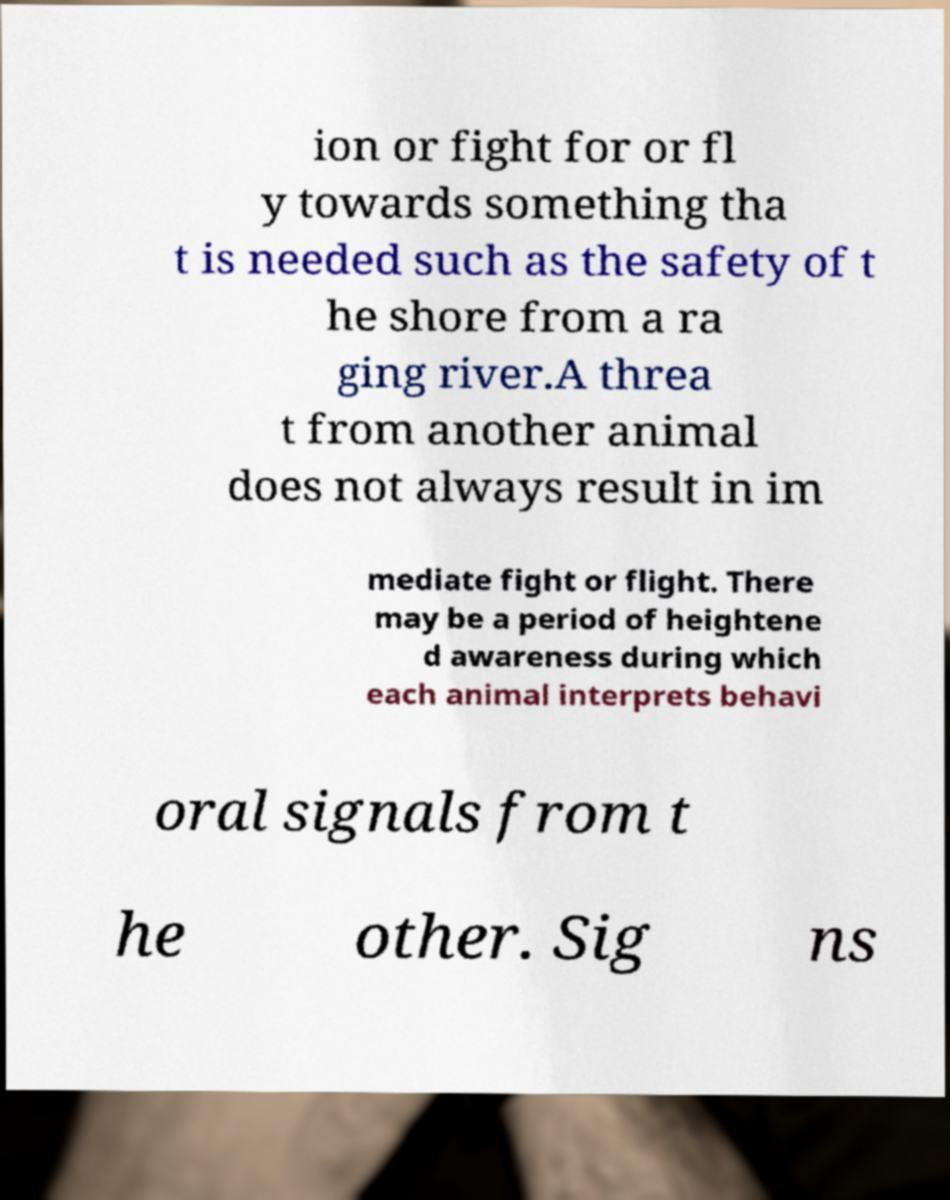Please read and relay the text visible in this image. What does it say? ion or fight for or fl y towards something tha t is needed such as the safety of t he shore from a ra ging river.A threa t from another animal does not always result in im mediate fight or flight. There may be a period of heightene d awareness during which each animal interprets behavi oral signals from t he other. Sig ns 